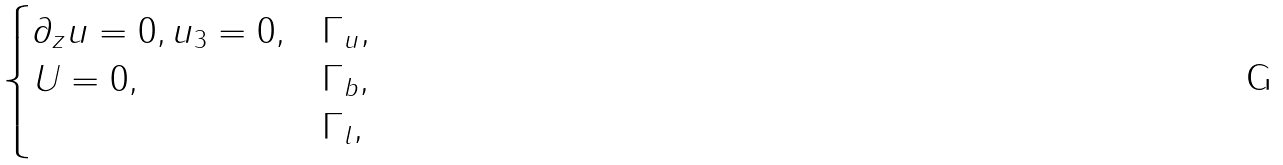<formula> <loc_0><loc_0><loc_500><loc_500>\begin{cases} \partial _ { z } u = 0 , u _ { 3 } = 0 , & \Gamma _ { u } , \\ U = 0 , & \Gamma _ { b } , \\ & \Gamma _ { l } , \end{cases}</formula> 